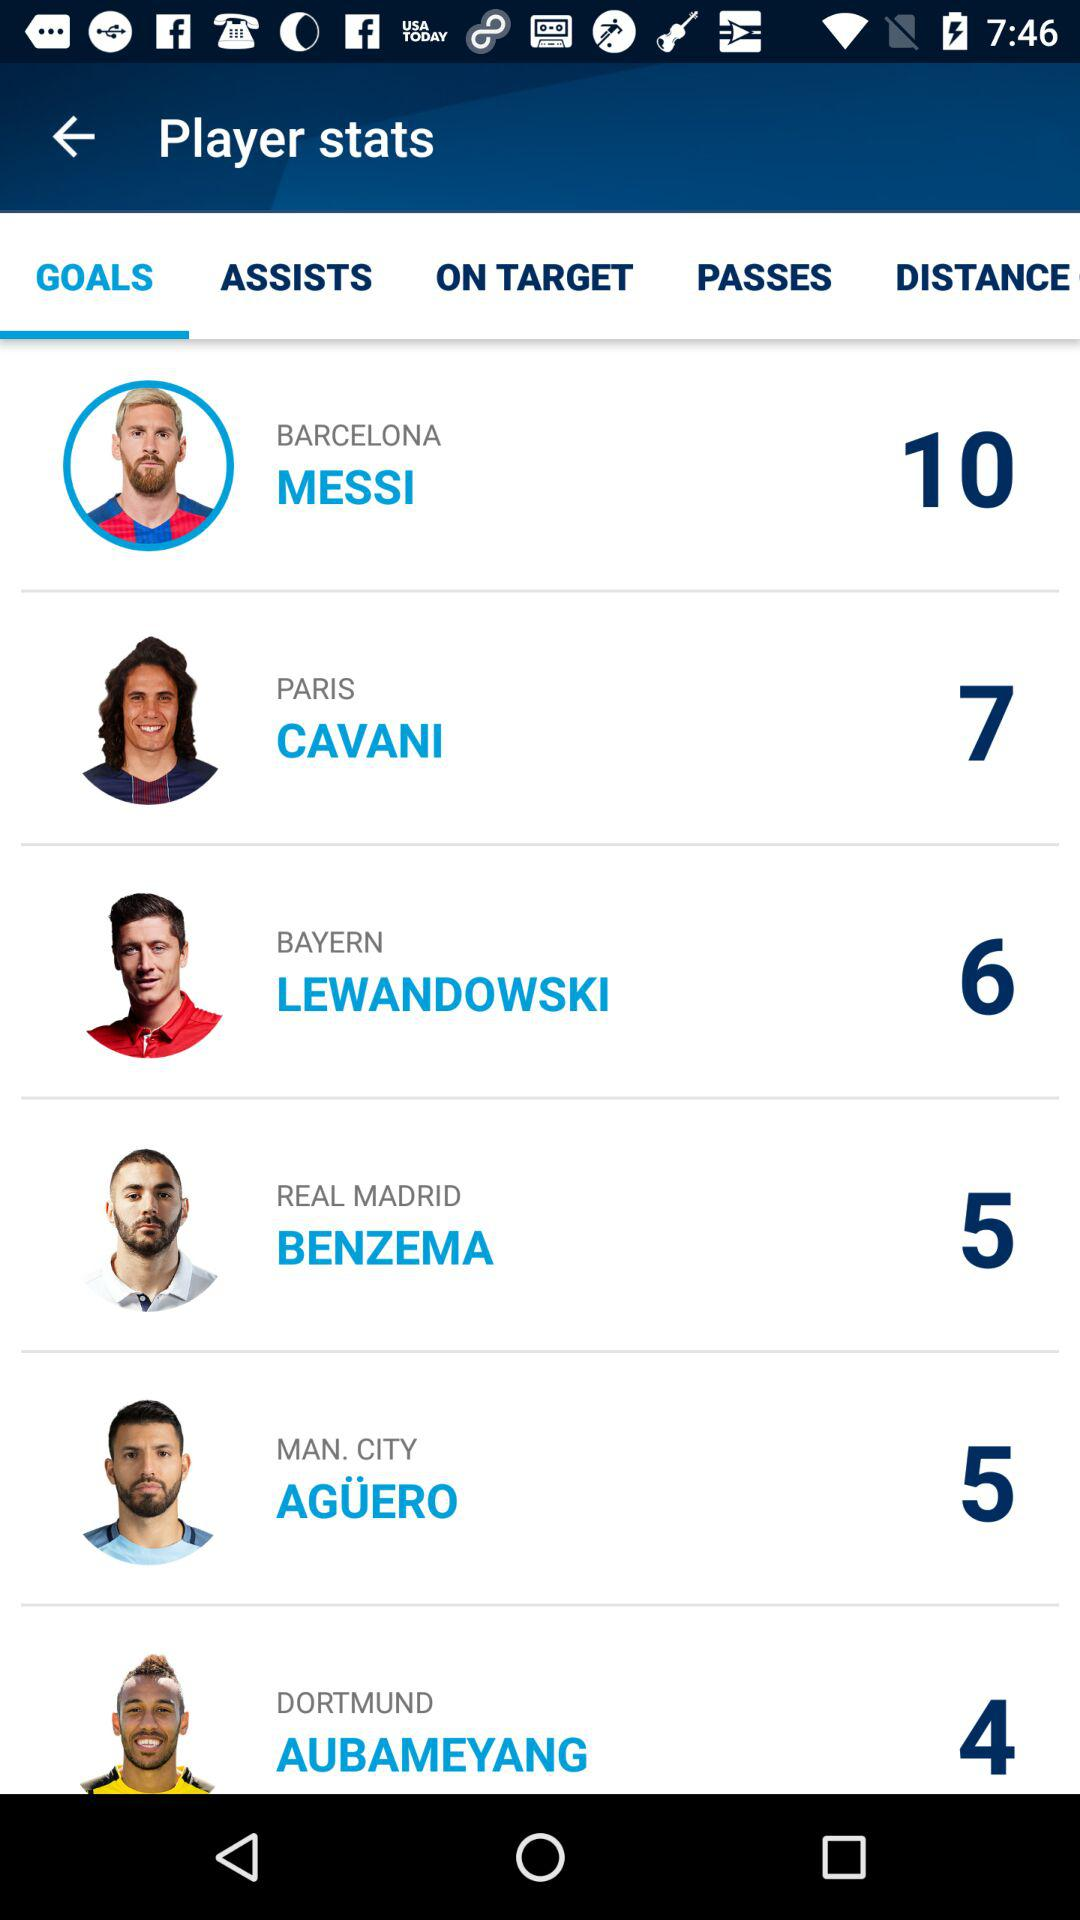How many goals by Cavani are there? There are 7 goals by Cavani. 